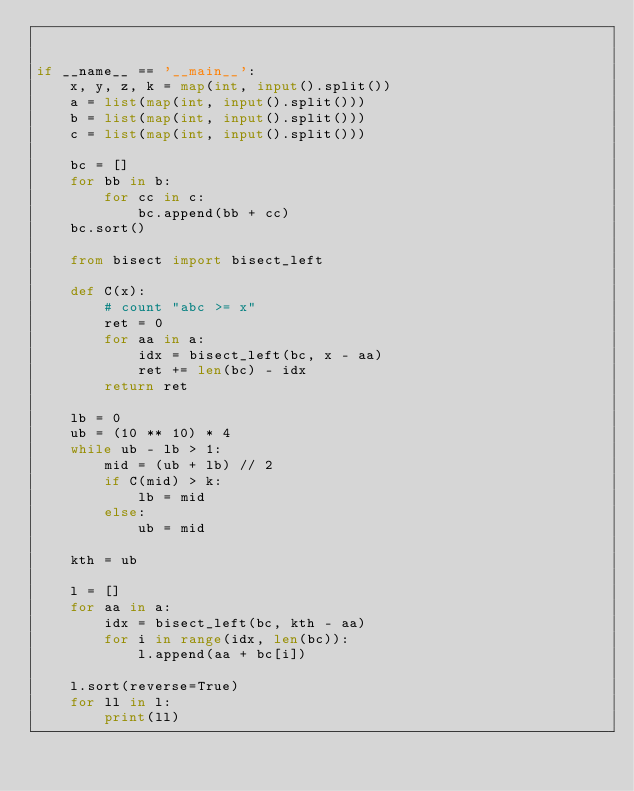Convert code to text. <code><loc_0><loc_0><loc_500><loc_500><_Python_>

if __name__ == '__main__':
    x, y, z, k = map(int, input().split())
    a = list(map(int, input().split()))
    b = list(map(int, input().split()))
    c = list(map(int, input().split()))

    bc = []
    for bb in b:
        for cc in c:
            bc.append(bb + cc)
    bc.sort()

    from bisect import bisect_left

    def C(x):
        # count "abc >= x"
        ret = 0
        for aa in a:
            idx = bisect_left(bc, x - aa)
            ret += len(bc) - idx
        return ret

    lb = 0
    ub = (10 ** 10) * 4
    while ub - lb > 1:
        mid = (ub + lb) // 2
        if C(mid) > k:
            lb = mid
        else:
            ub = mid

    kth = ub

    l = []
    for aa in a:
        idx = bisect_left(bc, kth - aa)
        for i in range(idx, len(bc)):
            l.append(aa + bc[i])

    l.sort(reverse=True)
    for ll in l:
        print(ll)
</code> 